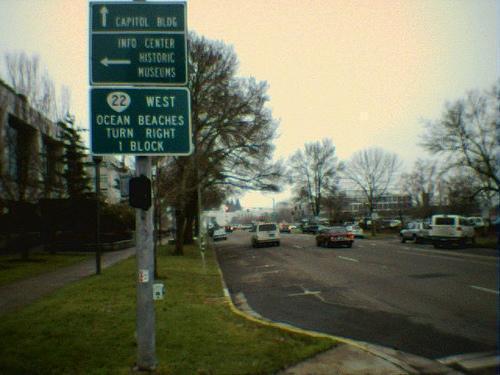What type of signs are these?
Select the accurate response from the four choices given to answer the question.
Options: Directional, warning, brand, regulatory. Directional. 